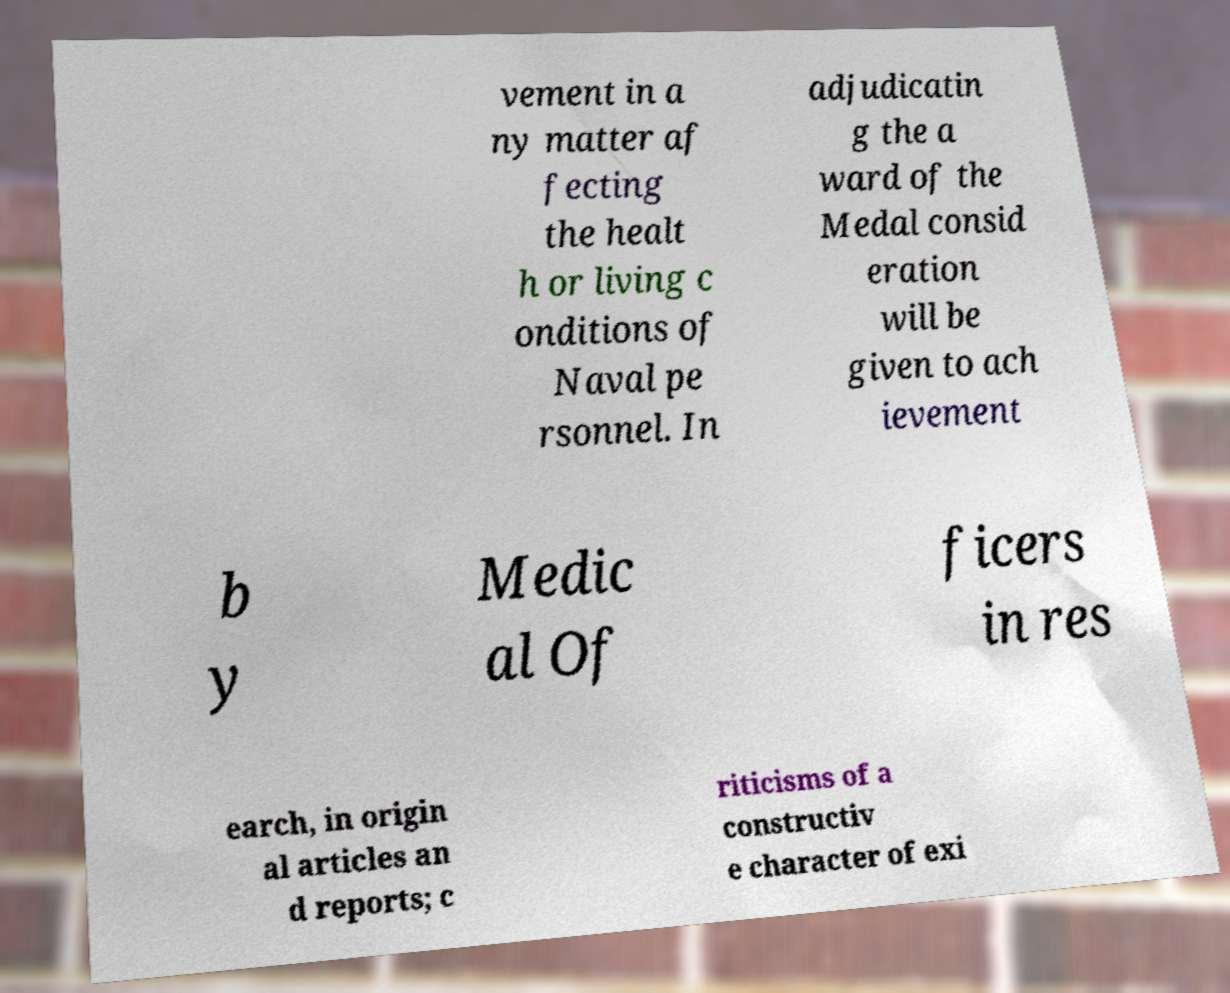For documentation purposes, I need the text within this image transcribed. Could you provide that? vement in a ny matter af fecting the healt h or living c onditions of Naval pe rsonnel. In adjudicatin g the a ward of the Medal consid eration will be given to ach ievement b y Medic al Of ficers in res earch, in origin al articles an d reports; c riticisms of a constructiv e character of exi 